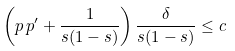<formula> <loc_0><loc_0><loc_500><loc_500>\left ( p \, p ^ { \prime } + \frac { 1 } { s ( 1 - s ) } \right ) \frac { \delta } { s ( 1 - s ) } \leq c</formula> 